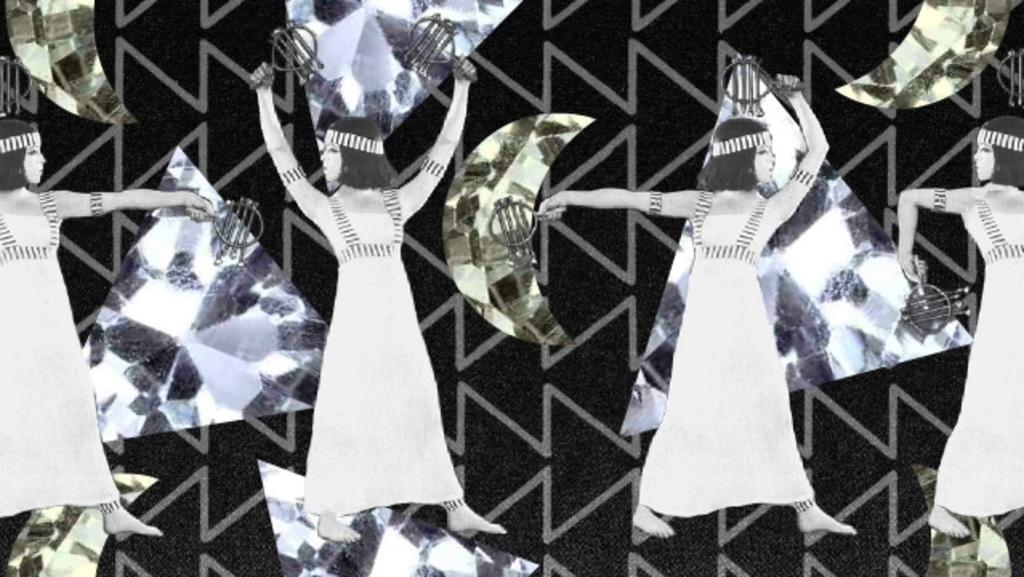How many women are present in the image? There are four women in the image. What are the women holding in their hands? The women are holding objects in their hands. Can you describe anything in the background of the image? Yes, there are stickers visible in the background of the image. What type of noise can be heard coming from the island in the image? There is no island present in the image, so it's not possible to determine what, if any, noise might be heard. 